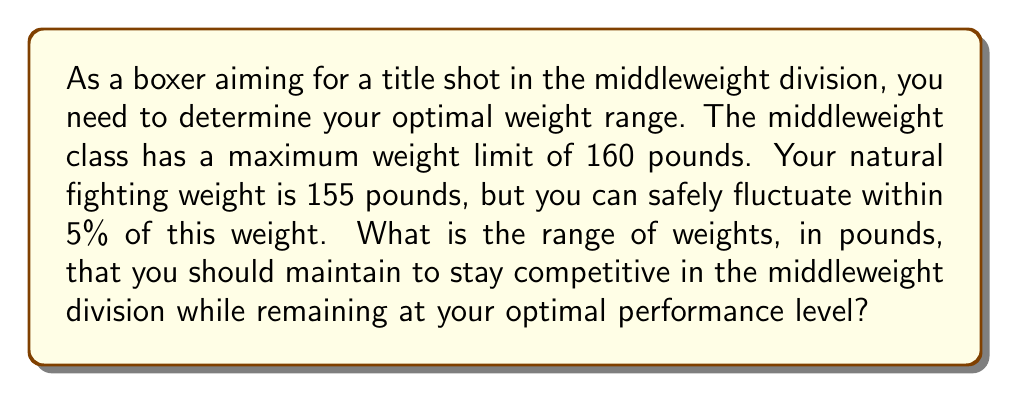Can you solve this math problem? To solve this problem, we need to follow these steps:

1. Calculate the lower and upper bounds of the 5% weight fluctuation:
   
   Lower bound: $155 - (155 \times 0.05) = 155 - 7.75 = 147.25$ pounds
   Upper bound: $155 + (155 \times 0.05) = 155 + 7.75 = 162.75$ pounds

2. Compare the calculated bounds with the middleweight division limit:
   
   The upper bound (162.75 pounds) exceeds the middleweight limit of 160 pounds.

3. Adjust the upper bound to the division limit:
   
   New upper bound: 160 pounds

4. Express the optimal weight range as an inequality:

   $$147.25 \leq x \leq 160$$

   Where $x$ represents the boxer's weight in pounds.

5. Round the lower bound to the nearest quarter-pound for practicality:

   $$147.25 \approx 147.25$$

Therefore, the optimal weight range for the boxer is between 147.25 and 160 pounds.
Answer: $147.25 \leq x \leq 160$, where $x$ is the boxer's weight in pounds 